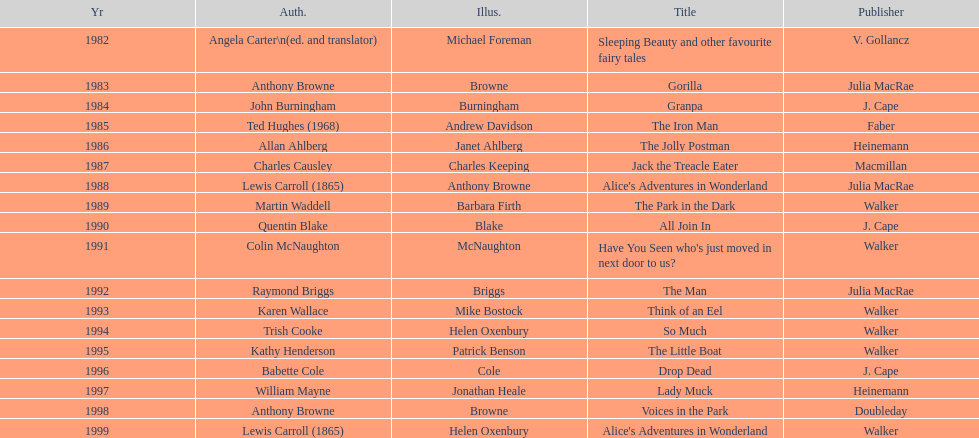How many number of titles are listed for the year 1991? 1. 